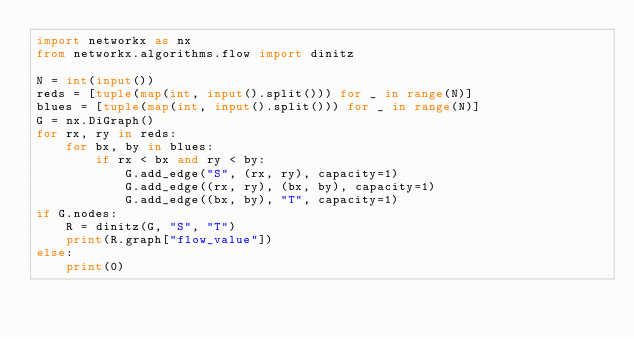<code> <loc_0><loc_0><loc_500><loc_500><_Python_>import networkx as nx
from networkx.algorithms.flow import dinitz

N = int(input())
reds = [tuple(map(int, input().split())) for _ in range(N)]
blues = [tuple(map(int, input().split())) for _ in range(N)]
G = nx.DiGraph()
for rx, ry in reds:
    for bx, by in blues:
        if rx < bx and ry < by:
            G.add_edge("S", (rx, ry), capacity=1)
            G.add_edge((rx, ry), (bx, by), capacity=1)
            G.add_edge((bx, by), "T", capacity=1)
if G.nodes:
    R = dinitz(G, "S", "T")
    print(R.graph["flow_value"])
else:
    print(0)

</code> 